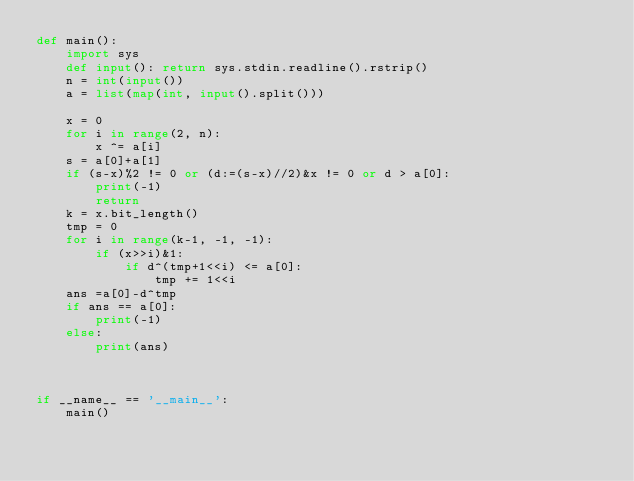Convert code to text. <code><loc_0><loc_0><loc_500><loc_500><_Python_>def main():
    import sys
    def input(): return sys.stdin.readline().rstrip()
    n = int(input())
    a = list(map(int, input().split()))

    x = 0
    for i in range(2, n):
        x ^= a[i]
    s = a[0]+a[1]
    if (s-x)%2 != 0 or (d:=(s-x)//2)&x != 0 or d > a[0]:
        print(-1)
        return
    k = x.bit_length()
    tmp = 0
    for i in range(k-1, -1, -1):
        if (x>>i)&1:
            if d^(tmp+1<<i) <= a[0]:
                tmp += 1<<i
    ans =a[0]-d^tmp
    if ans == a[0]:
        print(-1)
    else:
        print(ans)



if __name__ == '__main__':
    main()</code> 